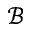Convert formula to latex. <formula><loc_0><loc_0><loc_500><loc_500>\mathcal { B }</formula> 